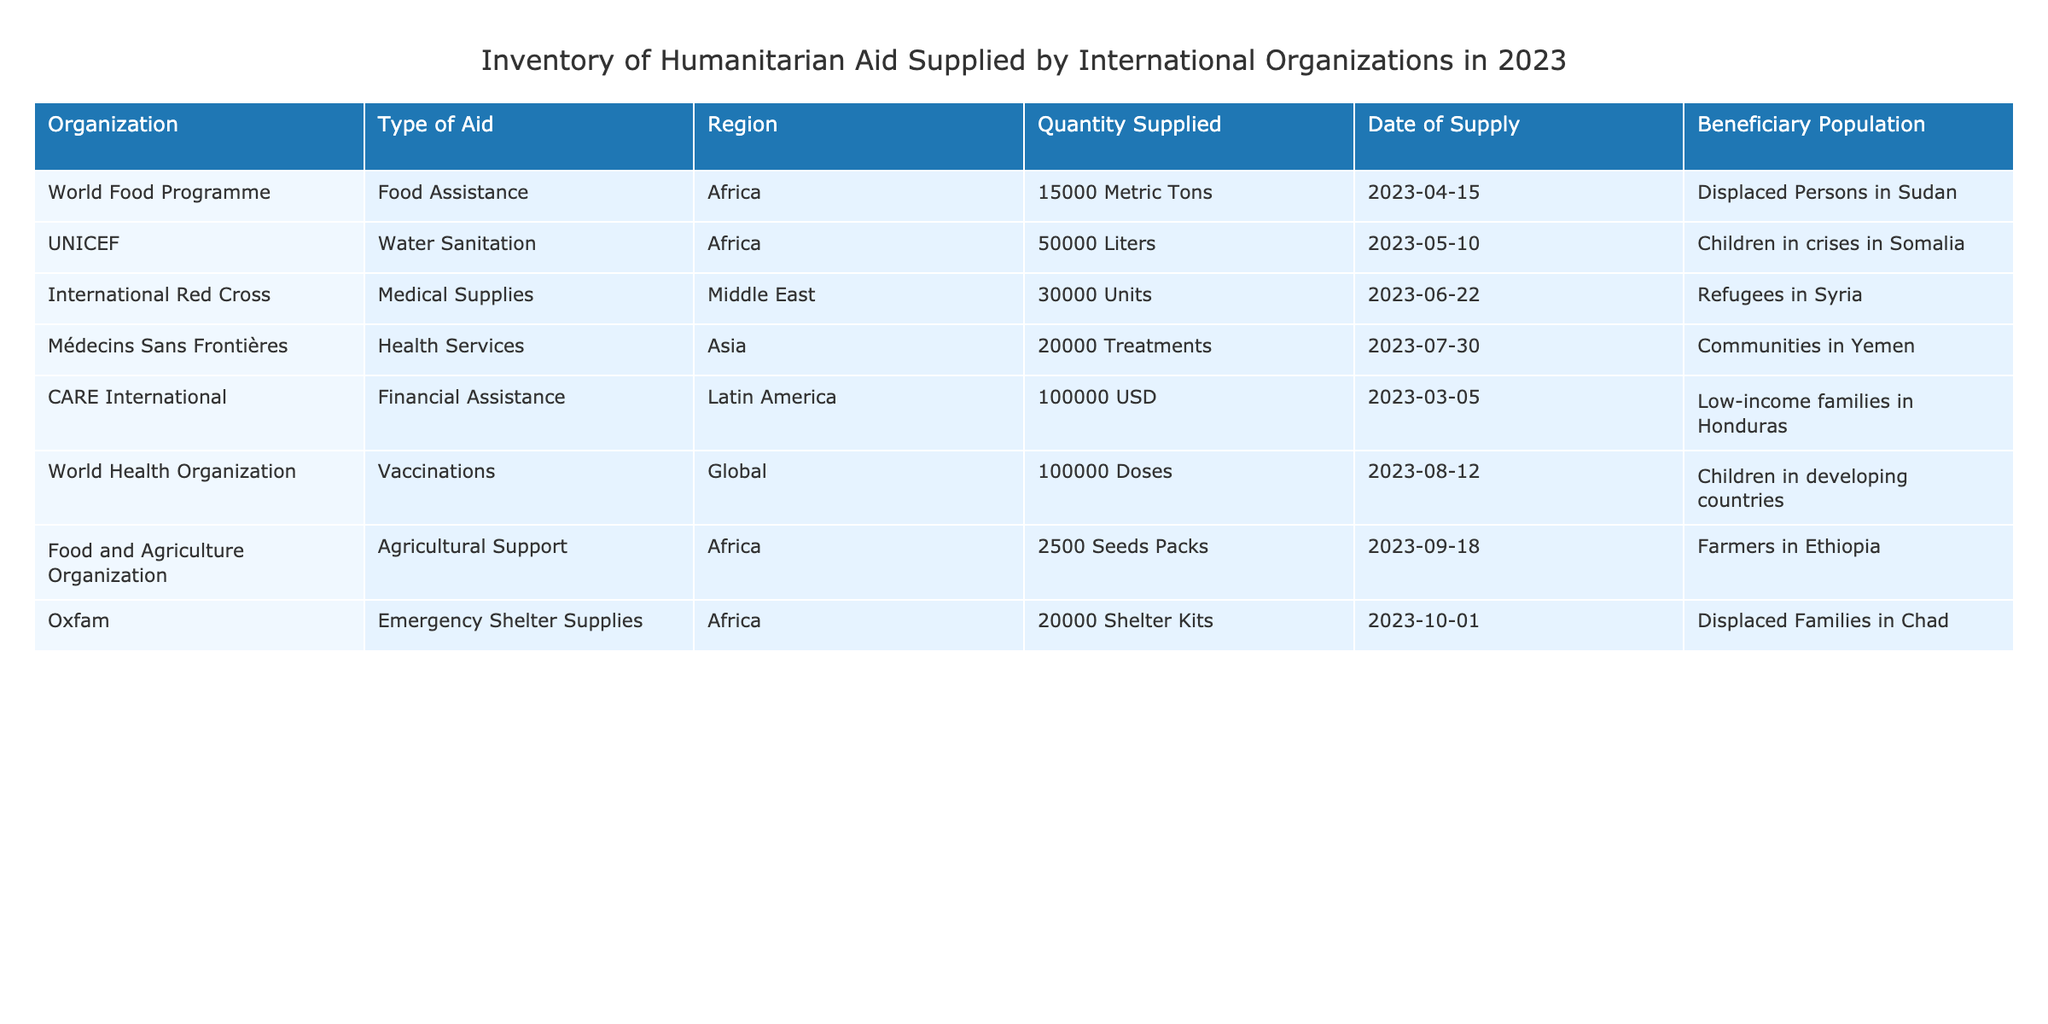What type of aid did the International Red Cross supply? The table shows the organization named International Red Cross and the type of aid listed in the corresponding row, which is Medical Supplies.
Answer: Medical Supplies How many liters of water sanitation aid did UNICEF supply? Looking at the row with UNICEF in the table, the quantity of water sanitation aid supplied is found to be 50000 Liters.
Answer: 50000 Liters What is the total quantity of food assistance and medical supplies supplied to Africa in 2023? The table lists two specific quantities for Africa: 15000 Metric Tons of Food Assistance from the World Food Programme and no medical supplies from any organization. Since there is no medical supply, we only consider food assistance, so the total is 15000 Metric Tons.
Answer: 15000 Metric Tons Did CARE International provide any type of aid in Africa? Checking the organization CARE International in the table, it indicates that they supplied Financial Assistance, and the region is Latin America, not Africa. Thus, it is false that CARE International provided aid in Africa.
Answer: No Which organization supplied the highest quantity of aid in 2023? By reviewing the table, the largest quantity is attributed to CARE International, which supplied 100000 USD in Financial Assistance. Therefore, it has the highest quantity when considering all forms of aid as a common denominator of value.
Answer: CARE International What is the difference in quantity between the aid supplied by UNICEF and the World Health Organization? UNICEF supplied 50000 Liters of Water Sanitation, while the World Health Organization supplied 100000 Doses of Vaccinations, but since these are different types, we cannot simply subtract them as they are not comparable. Thus, the question lacks a suitable basis for comparison.
Answer: Not comparable What type of help was offered to displaced families in Chad? In the table, the organization Oxfam is associated with Emergency Shelter Supplies, specifically for Displaced Families in Chad, which directly indicates the nature of assistance.
Answer: Emergency Shelter Supplies What percentage of the total aid supplied was in the form of Financial Assistance? First, we need to sum all the quantities in terms of a standard measure. Converting financial aid to a similar measure for various forms, which complicates calculations, gives a total aid value of 15000 Metric Tons + 50000 Liters + 30000 Units + 20000 Treatments + 100000 USD + 100000 Doses + 2500 Seed Packs + 20000 Shelter Kits. Financial assistance alone is counted as 100000 USD out of this cumulative sum. Therefore, the calculation reveals that Financial Assistance constitutes approximately 24% of total aid.
Answer: 24% What is the beneficiary population for health services supplied by Médecins Sans Frontières? In the table, by locating the relevant row for Médecins Sans Frontières, we see that the beneficiary population is stated as Communities in Yemen. Thus the answer is derived directly from that specific entry.
Answer: Communities in Yemen 